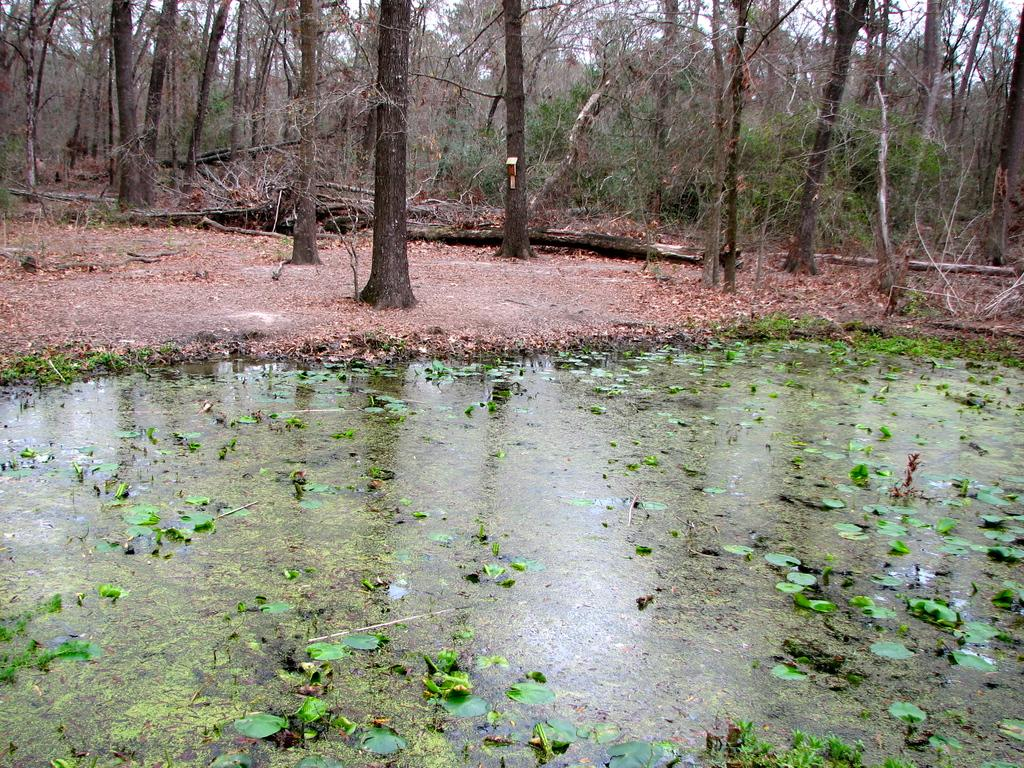What is the primary feature of the image? There are many trees in the image. What is happening to the leaves in the image? Leaves are floating on the water at the bottom of the image. What part of the natural environment is visible in the image? The sky is visible at the top of the image. What can be seen on the right side of the image? There are fallen tree woods on the right side of the image. Where is the hose connected to in the image? There is no hose present in the image. What type of bird is sitting on the fallen tree woods? There are no birds visible in the image, including hens. 